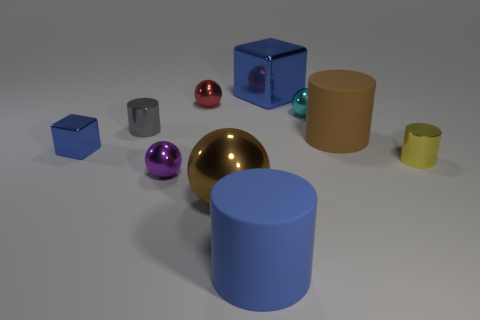Subtract all green cylinders. Subtract all brown cubes. How many cylinders are left? 4 Subtract all cylinders. How many objects are left? 6 Subtract all large blue blocks. Subtract all gray things. How many objects are left? 8 Add 1 big things. How many big things are left? 5 Add 8 yellow metal cylinders. How many yellow metal cylinders exist? 9 Subtract 0 gray spheres. How many objects are left? 10 